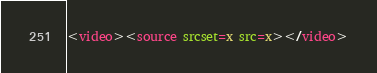<code> <loc_0><loc_0><loc_500><loc_500><_HTML_><video><source srcset=x src=x></video></code> 